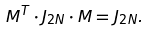<formula> <loc_0><loc_0><loc_500><loc_500>M ^ { T } \cdot J _ { 2 N } \cdot M = J _ { 2 N } .</formula> 